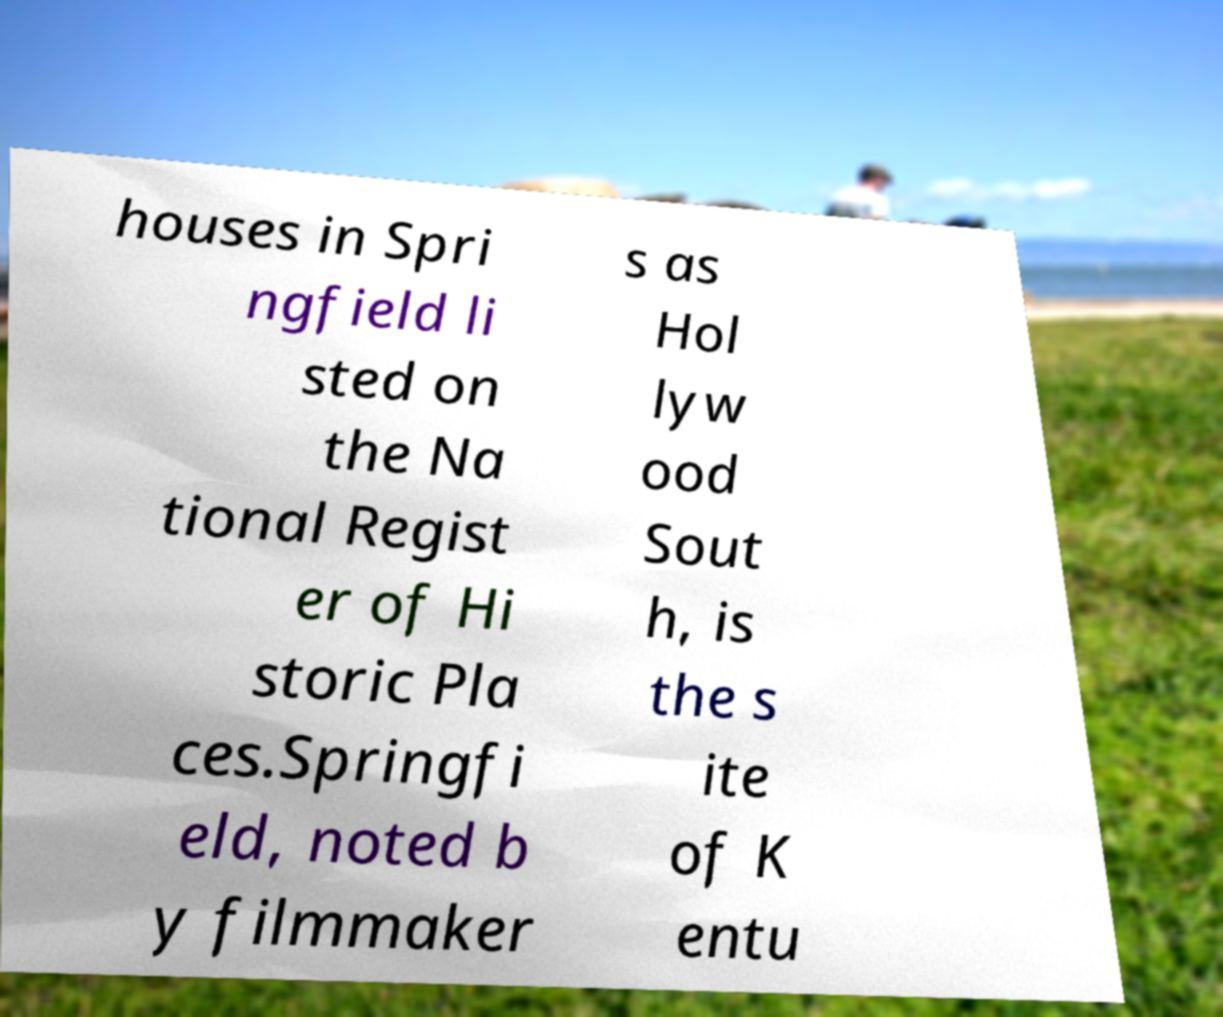Can you accurately transcribe the text from the provided image for me? houses in Spri ngfield li sted on the Na tional Regist er of Hi storic Pla ces.Springfi eld, noted b y filmmaker s as Hol lyw ood Sout h, is the s ite of K entu 